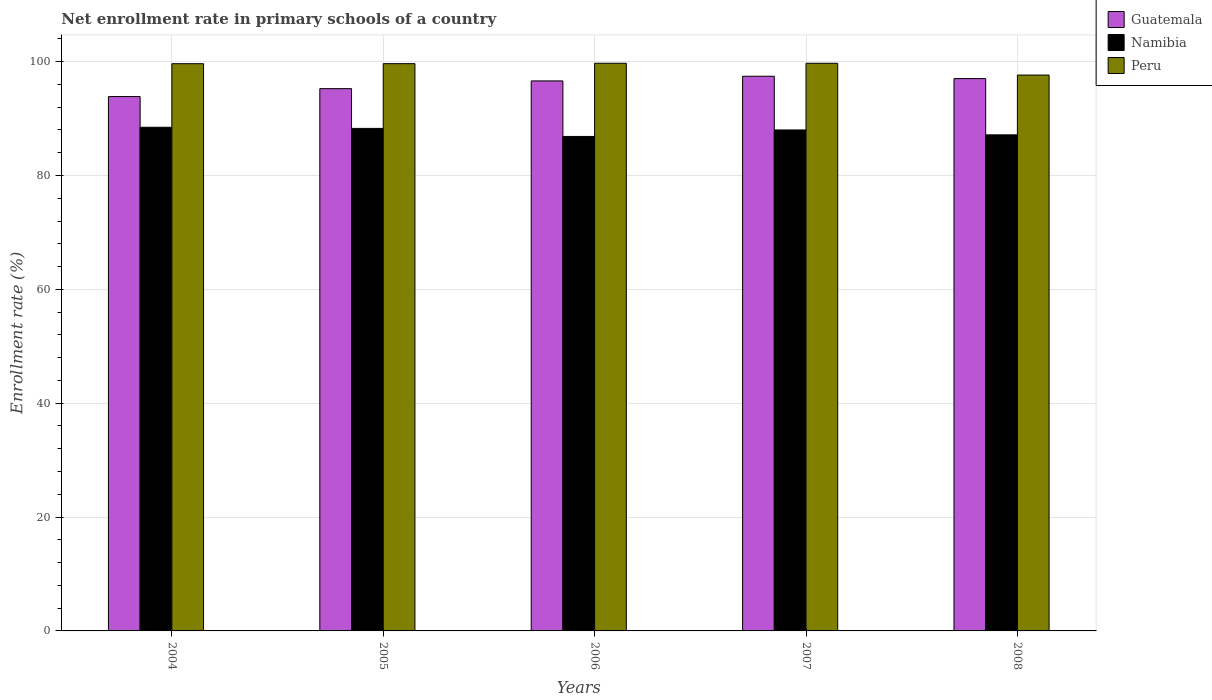How many bars are there on the 1st tick from the right?
Your answer should be compact. 3. In how many cases, is the number of bars for a given year not equal to the number of legend labels?
Your answer should be very brief. 0. What is the enrollment rate in primary schools in Namibia in 2006?
Make the answer very short. 86.86. Across all years, what is the maximum enrollment rate in primary schools in Guatemala?
Keep it short and to the point. 97.43. Across all years, what is the minimum enrollment rate in primary schools in Namibia?
Offer a very short reply. 86.86. In which year was the enrollment rate in primary schools in Namibia maximum?
Offer a terse response. 2004. What is the total enrollment rate in primary schools in Peru in the graph?
Your response must be concise. 496.33. What is the difference between the enrollment rate in primary schools in Peru in 2006 and that in 2007?
Keep it short and to the point. 0. What is the difference between the enrollment rate in primary schools in Guatemala in 2008 and the enrollment rate in primary schools in Namibia in 2007?
Provide a succinct answer. 9.03. What is the average enrollment rate in primary schools in Peru per year?
Ensure brevity in your answer.  99.27. In the year 2008, what is the difference between the enrollment rate in primary schools in Guatemala and enrollment rate in primary schools in Peru?
Provide a short and direct response. -0.62. What is the ratio of the enrollment rate in primary schools in Namibia in 2004 to that in 2006?
Make the answer very short. 1.02. Is the enrollment rate in primary schools in Namibia in 2005 less than that in 2008?
Make the answer very short. No. Is the difference between the enrollment rate in primary schools in Guatemala in 2004 and 2008 greater than the difference between the enrollment rate in primary schools in Peru in 2004 and 2008?
Offer a very short reply. No. What is the difference between the highest and the second highest enrollment rate in primary schools in Namibia?
Keep it short and to the point. 0.2. What is the difference between the highest and the lowest enrollment rate in primary schools in Guatemala?
Offer a terse response. 3.57. In how many years, is the enrollment rate in primary schools in Peru greater than the average enrollment rate in primary schools in Peru taken over all years?
Your answer should be compact. 4. Is the sum of the enrollment rate in primary schools in Namibia in 2005 and 2007 greater than the maximum enrollment rate in primary schools in Peru across all years?
Ensure brevity in your answer.  Yes. What does the 2nd bar from the left in 2006 represents?
Ensure brevity in your answer.  Namibia. Are all the bars in the graph horizontal?
Offer a terse response. No. How many years are there in the graph?
Make the answer very short. 5. What is the difference between two consecutive major ticks on the Y-axis?
Ensure brevity in your answer.  20. Are the values on the major ticks of Y-axis written in scientific E-notation?
Provide a short and direct response. No. Does the graph contain any zero values?
Ensure brevity in your answer.  No. What is the title of the graph?
Make the answer very short. Net enrollment rate in primary schools of a country. Does "Central African Republic" appear as one of the legend labels in the graph?
Keep it short and to the point. No. What is the label or title of the X-axis?
Make the answer very short. Years. What is the label or title of the Y-axis?
Give a very brief answer. Enrollment rate (%). What is the Enrollment rate (%) in Guatemala in 2004?
Your answer should be compact. 93.86. What is the Enrollment rate (%) of Namibia in 2004?
Ensure brevity in your answer.  88.47. What is the Enrollment rate (%) in Peru in 2004?
Your answer should be very brief. 99.63. What is the Enrollment rate (%) of Guatemala in 2005?
Your answer should be compact. 95.25. What is the Enrollment rate (%) in Namibia in 2005?
Give a very brief answer. 88.27. What is the Enrollment rate (%) in Peru in 2005?
Your response must be concise. 99.64. What is the Enrollment rate (%) of Guatemala in 2006?
Offer a terse response. 96.61. What is the Enrollment rate (%) of Namibia in 2006?
Make the answer very short. 86.86. What is the Enrollment rate (%) in Peru in 2006?
Ensure brevity in your answer.  99.71. What is the Enrollment rate (%) in Guatemala in 2007?
Give a very brief answer. 97.43. What is the Enrollment rate (%) in Namibia in 2007?
Offer a very short reply. 87.99. What is the Enrollment rate (%) of Peru in 2007?
Offer a very short reply. 99.71. What is the Enrollment rate (%) in Guatemala in 2008?
Your response must be concise. 97.02. What is the Enrollment rate (%) in Namibia in 2008?
Provide a short and direct response. 87.13. What is the Enrollment rate (%) of Peru in 2008?
Your answer should be very brief. 97.64. Across all years, what is the maximum Enrollment rate (%) in Guatemala?
Offer a terse response. 97.43. Across all years, what is the maximum Enrollment rate (%) in Namibia?
Offer a terse response. 88.47. Across all years, what is the maximum Enrollment rate (%) of Peru?
Give a very brief answer. 99.71. Across all years, what is the minimum Enrollment rate (%) of Guatemala?
Make the answer very short. 93.86. Across all years, what is the minimum Enrollment rate (%) of Namibia?
Your response must be concise. 86.86. Across all years, what is the minimum Enrollment rate (%) in Peru?
Ensure brevity in your answer.  97.64. What is the total Enrollment rate (%) of Guatemala in the graph?
Offer a terse response. 480.16. What is the total Enrollment rate (%) of Namibia in the graph?
Ensure brevity in your answer.  438.72. What is the total Enrollment rate (%) in Peru in the graph?
Offer a very short reply. 496.33. What is the difference between the Enrollment rate (%) of Guatemala in 2004 and that in 2005?
Your response must be concise. -1.39. What is the difference between the Enrollment rate (%) of Namibia in 2004 and that in 2005?
Offer a very short reply. 0.2. What is the difference between the Enrollment rate (%) of Peru in 2004 and that in 2005?
Give a very brief answer. -0. What is the difference between the Enrollment rate (%) of Guatemala in 2004 and that in 2006?
Offer a terse response. -2.75. What is the difference between the Enrollment rate (%) in Namibia in 2004 and that in 2006?
Give a very brief answer. 1.61. What is the difference between the Enrollment rate (%) of Peru in 2004 and that in 2006?
Give a very brief answer. -0.08. What is the difference between the Enrollment rate (%) of Guatemala in 2004 and that in 2007?
Provide a succinct answer. -3.57. What is the difference between the Enrollment rate (%) in Namibia in 2004 and that in 2007?
Your response must be concise. 0.47. What is the difference between the Enrollment rate (%) of Peru in 2004 and that in 2007?
Make the answer very short. -0.07. What is the difference between the Enrollment rate (%) in Guatemala in 2004 and that in 2008?
Keep it short and to the point. -3.16. What is the difference between the Enrollment rate (%) in Namibia in 2004 and that in 2008?
Provide a short and direct response. 1.33. What is the difference between the Enrollment rate (%) in Peru in 2004 and that in 2008?
Offer a very short reply. 2. What is the difference between the Enrollment rate (%) in Guatemala in 2005 and that in 2006?
Give a very brief answer. -1.36. What is the difference between the Enrollment rate (%) of Namibia in 2005 and that in 2006?
Provide a succinct answer. 1.41. What is the difference between the Enrollment rate (%) of Peru in 2005 and that in 2006?
Ensure brevity in your answer.  -0.07. What is the difference between the Enrollment rate (%) in Guatemala in 2005 and that in 2007?
Keep it short and to the point. -2.18. What is the difference between the Enrollment rate (%) of Namibia in 2005 and that in 2007?
Ensure brevity in your answer.  0.27. What is the difference between the Enrollment rate (%) in Peru in 2005 and that in 2007?
Give a very brief answer. -0.07. What is the difference between the Enrollment rate (%) of Guatemala in 2005 and that in 2008?
Provide a succinct answer. -1.77. What is the difference between the Enrollment rate (%) in Namibia in 2005 and that in 2008?
Keep it short and to the point. 1.13. What is the difference between the Enrollment rate (%) of Peru in 2005 and that in 2008?
Give a very brief answer. 2. What is the difference between the Enrollment rate (%) in Guatemala in 2006 and that in 2007?
Offer a very short reply. -0.82. What is the difference between the Enrollment rate (%) in Namibia in 2006 and that in 2007?
Make the answer very short. -1.14. What is the difference between the Enrollment rate (%) of Peru in 2006 and that in 2007?
Offer a very short reply. 0. What is the difference between the Enrollment rate (%) of Guatemala in 2006 and that in 2008?
Ensure brevity in your answer.  -0.41. What is the difference between the Enrollment rate (%) in Namibia in 2006 and that in 2008?
Your answer should be very brief. -0.28. What is the difference between the Enrollment rate (%) in Peru in 2006 and that in 2008?
Keep it short and to the point. 2.07. What is the difference between the Enrollment rate (%) of Guatemala in 2007 and that in 2008?
Make the answer very short. 0.41. What is the difference between the Enrollment rate (%) in Namibia in 2007 and that in 2008?
Your answer should be very brief. 0.86. What is the difference between the Enrollment rate (%) of Peru in 2007 and that in 2008?
Ensure brevity in your answer.  2.07. What is the difference between the Enrollment rate (%) of Guatemala in 2004 and the Enrollment rate (%) of Namibia in 2005?
Offer a very short reply. 5.59. What is the difference between the Enrollment rate (%) in Guatemala in 2004 and the Enrollment rate (%) in Peru in 2005?
Your answer should be compact. -5.78. What is the difference between the Enrollment rate (%) in Namibia in 2004 and the Enrollment rate (%) in Peru in 2005?
Keep it short and to the point. -11.17. What is the difference between the Enrollment rate (%) of Guatemala in 2004 and the Enrollment rate (%) of Namibia in 2006?
Offer a terse response. 7. What is the difference between the Enrollment rate (%) of Guatemala in 2004 and the Enrollment rate (%) of Peru in 2006?
Your answer should be compact. -5.85. What is the difference between the Enrollment rate (%) of Namibia in 2004 and the Enrollment rate (%) of Peru in 2006?
Offer a very short reply. -11.24. What is the difference between the Enrollment rate (%) in Guatemala in 2004 and the Enrollment rate (%) in Namibia in 2007?
Make the answer very short. 5.86. What is the difference between the Enrollment rate (%) in Guatemala in 2004 and the Enrollment rate (%) in Peru in 2007?
Your answer should be compact. -5.85. What is the difference between the Enrollment rate (%) of Namibia in 2004 and the Enrollment rate (%) of Peru in 2007?
Provide a succinct answer. -11.24. What is the difference between the Enrollment rate (%) of Guatemala in 2004 and the Enrollment rate (%) of Namibia in 2008?
Offer a terse response. 6.72. What is the difference between the Enrollment rate (%) in Guatemala in 2004 and the Enrollment rate (%) in Peru in 2008?
Provide a succinct answer. -3.78. What is the difference between the Enrollment rate (%) in Namibia in 2004 and the Enrollment rate (%) in Peru in 2008?
Give a very brief answer. -9.17. What is the difference between the Enrollment rate (%) in Guatemala in 2005 and the Enrollment rate (%) in Namibia in 2006?
Your answer should be compact. 8.4. What is the difference between the Enrollment rate (%) of Guatemala in 2005 and the Enrollment rate (%) of Peru in 2006?
Your answer should be very brief. -4.46. What is the difference between the Enrollment rate (%) of Namibia in 2005 and the Enrollment rate (%) of Peru in 2006?
Offer a very short reply. -11.44. What is the difference between the Enrollment rate (%) in Guatemala in 2005 and the Enrollment rate (%) in Namibia in 2007?
Your answer should be compact. 7.26. What is the difference between the Enrollment rate (%) in Guatemala in 2005 and the Enrollment rate (%) in Peru in 2007?
Provide a succinct answer. -4.46. What is the difference between the Enrollment rate (%) in Namibia in 2005 and the Enrollment rate (%) in Peru in 2007?
Keep it short and to the point. -11.44. What is the difference between the Enrollment rate (%) of Guatemala in 2005 and the Enrollment rate (%) of Namibia in 2008?
Make the answer very short. 8.12. What is the difference between the Enrollment rate (%) of Guatemala in 2005 and the Enrollment rate (%) of Peru in 2008?
Give a very brief answer. -2.39. What is the difference between the Enrollment rate (%) of Namibia in 2005 and the Enrollment rate (%) of Peru in 2008?
Provide a short and direct response. -9.37. What is the difference between the Enrollment rate (%) in Guatemala in 2006 and the Enrollment rate (%) in Namibia in 2007?
Provide a succinct answer. 8.61. What is the difference between the Enrollment rate (%) of Guatemala in 2006 and the Enrollment rate (%) of Peru in 2007?
Your response must be concise. -3.1. What is the difference between the Enrollment rate (%) in Namibia in 2006 and the Enrollment rate (%) in Peru in 2007?
Your answer should be compact. -12.85. What is the difference between the Enrollment rate (%) of Guatemala in 2006 and the Enrollment rate (%) of Namibia in 2008?
Provide a succinct answer. 9.47. What is the difference between the Enrollment rate (%) in Guatemala in 2006 and the Enrollment rate (%) in Peru in 2008?
Provide a short and direct response. -1.03. What is the difference between the Enrollment rate (%) of Namibia in 2006 and the Enrollment rate (%) of Peru in 2008?
Offer a terse response. -10.78. What is the difference between the Enrollment rate (%) in Guatemala in 2007 and the Enrollment rate (%) in Namibia in 2008?
Offer a very short reply. 10.29. What is the difference between the Enrollment rate (%) of Guatemala in 2007 and the Enrollment rate (%) of Peru in 2008?
Your answer should be very brief. -0.21. What is the difference between the Enrollment rate (%) in Namibia in 2007 and the Enrollment rate (%) in Peru in 2008?
Your response must be concise. -9.64. What is the average Enrollment rate (%) in Guatemala per year?
Provide a short and direct response. 96.03. What is the average Enrollment rate (%) in Namibia per year?
Offer a very short reply. 87.74. What is the average Enrollment rate (%) of Peru per year?
Give a very brief answer. 99.27. In the year 2004, what is the difference between the Enrollment rate (%) of Guatemala and Enrollment rate (%) of Namibia?
Offer a very short reply. 5.39. In the year 2004, what is the difference between the Enrollment rate (%) in Guatemala and Enrollment rate (%) in Peru?
Offer a very short reply. -5.78. In the year 2004, what is the difference between the Enrollment rate (%) in Namibia and Enrollment rate (%) in Peru?
Give a very brief answer. -11.17. In the year 2005, what is the difference between the Enrollment rate (%) in Guatemala and Enrollment rate (%) in Namibia?
Ensure brevity in your answer.  6.98. In the year 2005, what is the difference between the Enrollment rate (%) of Guatemala and Enrollment rate (%) of Peru?
Keep it short and to the point. -4.39. In the year 2005, what is the difference between the Enrollment rate (%) in Namibia and Enrollment rate (%) in Peru?
Make the answer very short. -11.37. In the year 2006, what is the difference between the Enrollment rate (%) in Guatemala and Enrollment rate (%) in Namibia?
Offer a terse response. 9.75. In the year 2006, what is the difference between the Enrollment rate (%) in Guatemala and Enrollment rate (%) in Peru?
Offer a terse response. -3.1. In the year 2006, what is the difference between the Enrollment rate (%) in Namibia and Enrollment rate (%) in Peru?
Ensure brevity in your answer.  -12.86. In the year 2007, what is the difference between the Enrollment rate (%) in Guatemala and Enrollment rate (%) in Namibia?
Ensure brevity in your answer.  9.44. In the year 2007, what is the difference between the Enrollment rate (%) in Guatemala and Enrollment rate (%) in Peru?
Give a very brief answer. -2.28. In the year 2007, what is the difference between the Enrollment rate (%) of Namibia and Enrollment rate (%) of Peru?
Ensure brevity in your answer.  -11.71. In the year 2008, what is the difference between the Enrollment rate (%) of Guatemala and Enrollment rate (%) of Namibia?
Your answer should be compact. 9.88. In the year 2008, what is the difference between the Enrollment rate (%) in Guatemala and Enrollment rate (%) in Peru?
Keep it short and to the point. -0.62. In the year 2008, what is the difference between the Enrollment rate (%) in Namibia and Enrollment rate (%) in Peru?
Offer a terse response. -10.5. What is the ratio of the Enrollment rate (%) in Guatemala in 2004 to that in 2005?
Offer a very short reply. 0.99. What is the ratio of the Enrollment rate (%) of Peru in 2004 to that in 2005?
Provide a short and direct response. 1. What is the ratio of the Enrollment rate (%) in Guatemala in 2004 to that in 2006?
Your answer should be very brief. 0.97. What is the ratio of the Enrollment rate (%) in Namibia in 2004 to that in 2006?
Offer a very short reply. 1.02. What is the ratio of the Enrollment rate (%) in Guatemala in 2004 to that in 2007?
Give a very brief answer. 0.96. What is the ratio of the Enrollment rate (%) in Namibia in 2004 to that in 2007?
Your answer should be very brief. 1.01. What is the ratio of the Enrollment rate (%) in Guatemala in 2004 to that in 2008?
Your answer should be compact. 0.97. What is the ratio of the Enrollment rate (%) in Namibia in 2004 to that in 2008?
Provide a short and direct response. 1.02. What is the ratio of the Enrollment rate (%) of Peru in 2004 to that in 2008?
Keep it short and to the point. 1.02. What is the ratio of the Enrollment rate (%) of Guatemala in 2005 to that in 2006?
Provide a succinct answer. 0.99. What is the ratio of the Enrollment rate (%) of Namibia in 2005 to that in 2006?
Make the answer very short. 1.02. What is the ratio of the Enrollment rate (%) of Guatemala in 2005 to that in 2007?
Your answer should be very brief. 0.98. What is the ratio of the Enrollment rate (%) of Namibia in 2005 to that in 2007?
Keep it short and to the point. 1. What is the ratio of the Enrollment rate (%) in Peru in 2005 to that in 2007?
Give a very brief answer. 1. What is the ratio of the Enrollment rate (%) of Guatemala in 2005 to that in 2008?
Your answer should be compact. 0.98. What is the ratio of the Enrollment rate (%) of Peru in 2005 to that in 2008?
Keep it short and to the point. 1.02. What is the ratio of the Enrollment rate (%) of Guatemala in 2006 to that in 2007?
Your response must be concise. 0.99. What is the ratio of the Enrollment rate (%) of Namibia in 2006 to that in 2007?
Your answer should be compact. 0.99. What is the ratio of the Enrollment rate (%) in Guatemala in 2006 to that in 2008?
Make the answer very short. 1. What is the ratio of the Enrollment rate (%) in Namibia in 2006 to that in 2008?
Provide a short and direct response. 1. What is the ratio of the Enrollment rate (%) in Peru in 2006 to that in 2008?
Your response must be concise. 1.02. What is the ratio of the Enrollment rate (%) in Guatemala in 2007 to that in 2008?
Make the answer very short. 1. What is the ratio of the Enrollment rate (%) in Namibia in 2007 to that in 2008?
Provide a succinct answer. 1.01. What is the ratio of the Enrollment rate (%) of Peru in 2007 to that in 2008?
Make the answer very short. 1.02. What is the difference between the highest and the second highest Enrollment rate (%) of Guatemala?
Offer a terse response. 0.41. What is the difference between the highest and the second highest Enrollment rate (%) of Namibia?
Make the answer very short. 0.2. What is the difference between the highest and the second highest Enrollment rate (%) in Peru?
Give a very brief answer. 0. What is the difference between the highest and the lowest Enrollment rate (%) in Guatemala?
Provide a succinct answer. 3.57. What is the difference between the highest and the lowest Enrollment rate (%) of Namibia?
Provide a succinct answer. 1.61. What is the difference between the highest and the lowest Enrollment rate (%) of Peru?
Provide a short and direct response. 2.07. 